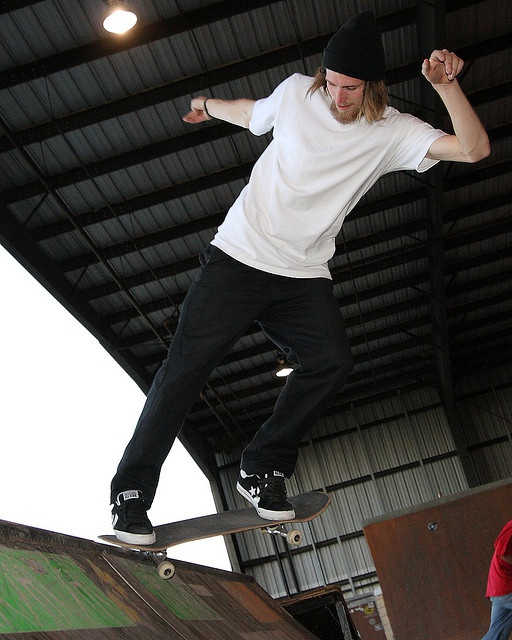Describe the objects in this image and their specific colors. I can see people in black, lightgray, darkgray, and gray tones, skateboard in black, gray, white, and darkgray tones, and people in black, brown, maroon, and gray tones in this image. 